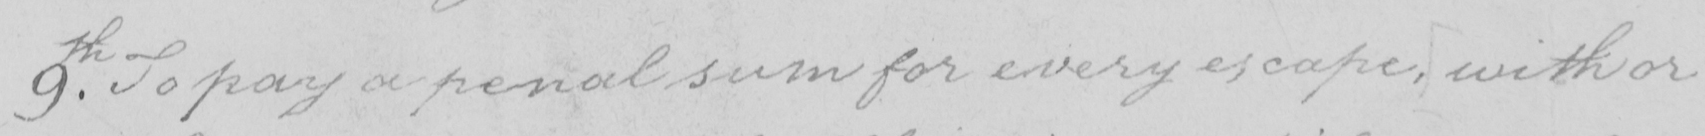What does this handwritten line say? 9th . To pay a penal sum for every escape , with or 